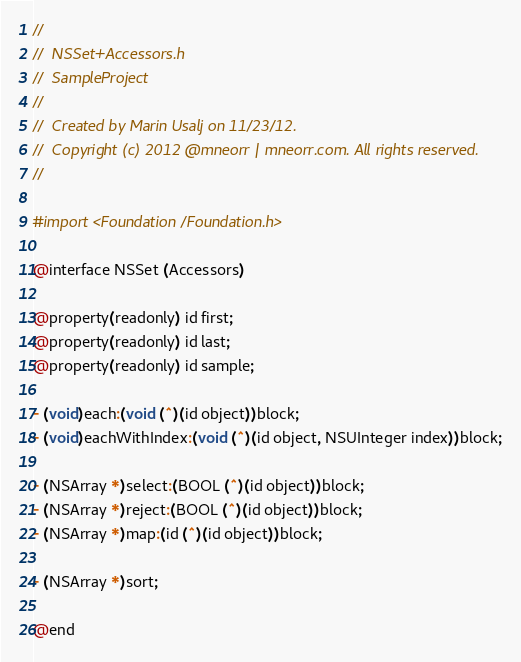<code> <loc_0><loc_0><loc_500><loc_500><_C_>//
//  NSSet+Accessors.h
//  SampleProject
//
//  Created by Marin Usalj on 11/23/12.
//  Copyright (c) 2012 @mneorr | mneorr.com. All rights reserved.
//

#import <Foundation/Foundation.h>

@interface NSSet (Accessors)

@property(readonly) id first;
@property(readonly) id last;
@property(readonly) id sample;

- (void)each:(void (^)(id object))block;
- (void)eachWithIndex:(void (^)(id object, NSUInteger index))block;

- (NSArray *)select:(BOOL (^)(id object))block;
- (NSArray *)reject:(BOOL (^)(id object))block;
- (NSArray *)map:(id (^)(id object))block;

- (NSArray *)sort;

@end
</code> 